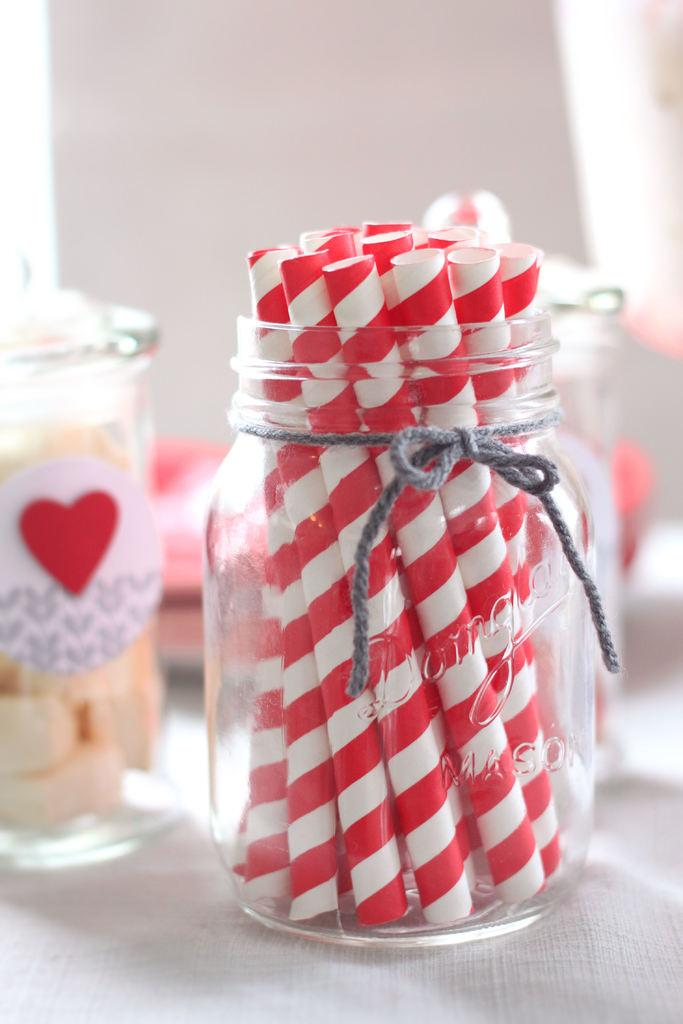What is one of the objects in the image? There is a bottle in the image. What is another object in the image? There is a glass in the image. What else can be seen in the image besides the bottle and glass? There are food items in the image. Where are the objects located in the image? The objects are on a platform. What is the color of the background in the image? The background of the image is white. How many rabbits are visible in the image? There are no rabbits present in the image. 